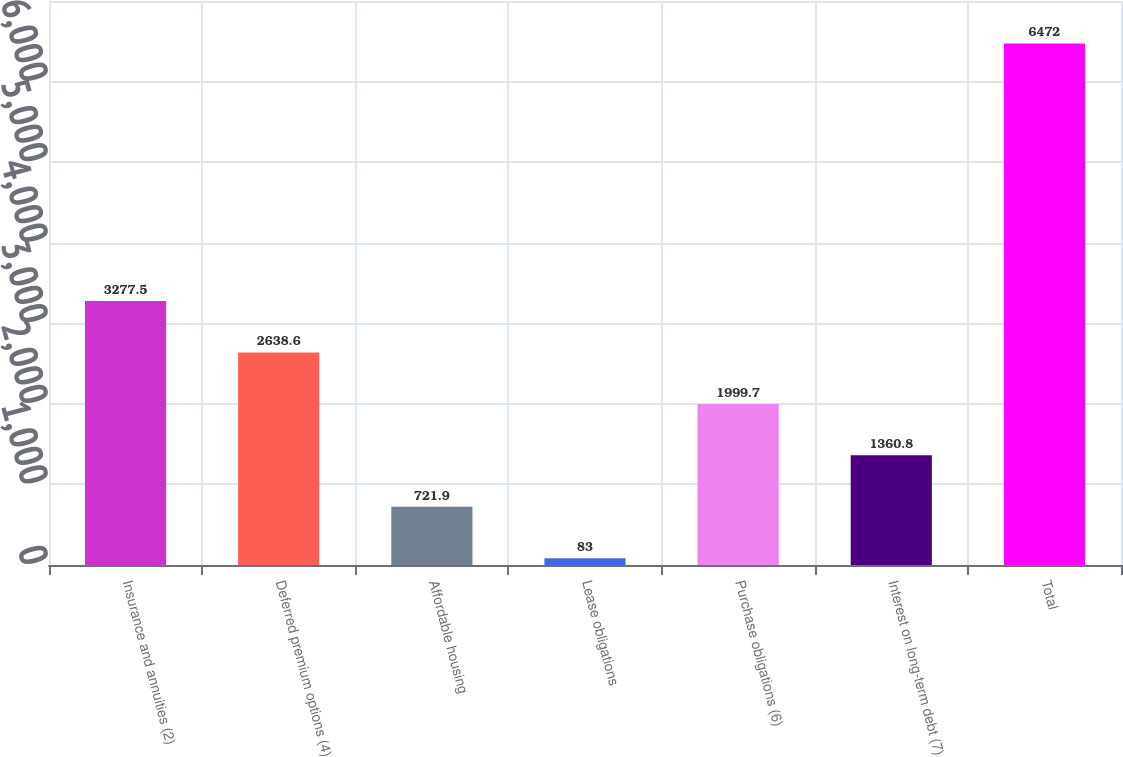Convert chart. <chart><loc_0><loc_0><loc_500><loc_500><bar_chart><fcel>Insurance and annuities (2)<fcel>Deferred premium options (4)<fcel>Affordable housing<fcel>Lease obligations<fcel>Purchase obligations (6)<fcel>Interest on long-term debt (7)<fcel>Total<nl><fcel>3277.5<fcel>2638.6<fcel>721.9<fcel>83<fcel>1999.7<fcel>1360.8<fcel>6472<nl></chart> 